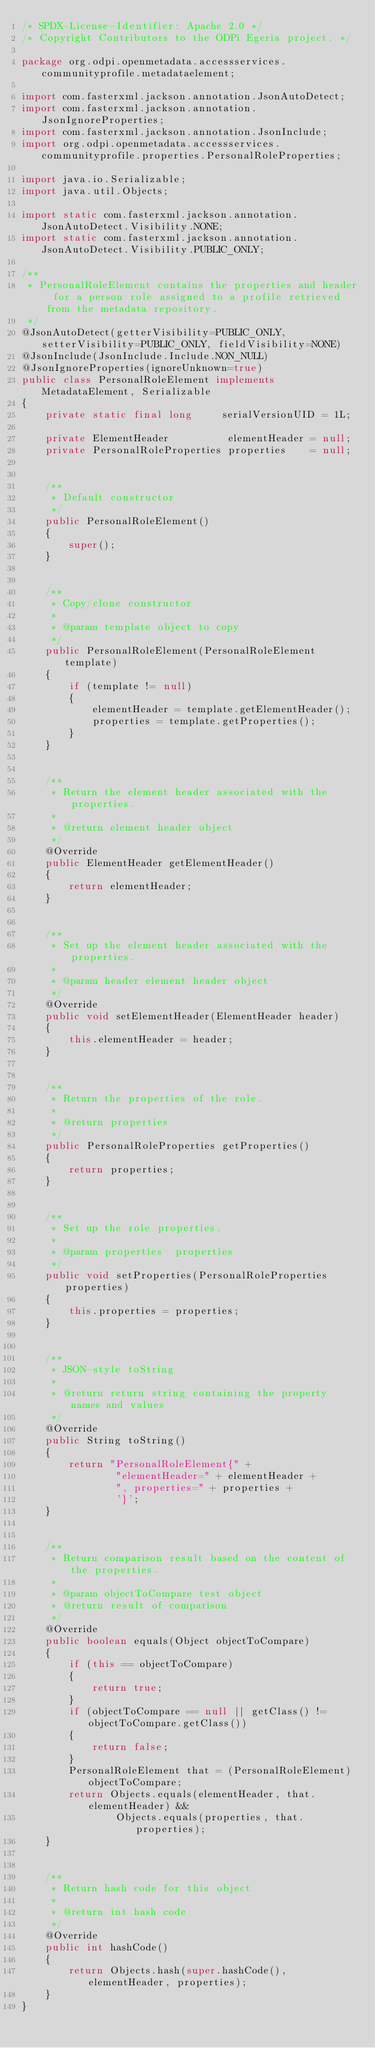<code> <loc_0><loc_0><loc_500><loc_500><_Java_>/* SPDX-License-Identifier: Apache 2.0 */
/* Copyright Contributors to the ODPi Egeria project. */

package org.odpi.openmetadata.accessservices.communityprofile.metadataelement;

import com.fasterxml.jackson.annotation.JsonAutoDetect;
import com.fasterxml.jackson.annotation.JsonIgnoreProperties;
import com.fasterxml.jackson.annotation.JsonInclude;
import org.odpi.openmetadata.accessservices.communityprofile.properties.PersonalRoleProperties;

import java.io.Serializable;
import java.util.Objects;

import static com.fasterxml.jackson.annotation.JsonAutoDetect.Visibility.NONE;
import static com.fasterxml.jackson.annotation.JsonAutoDetect.Visibility.PUBLIC_ONLY;

/**
 * PersonalRoleElement contains the properties and header for a person role assigned to a profile retrieved from the metadata repository.
 */
@JsonAutoDetect(getterVisibility=PUBLIC_ONLY, setterVisibility=PUBLIC_ONLY, fieldVisibility=NONE)
@JsonInclude(JsonInclude.Include.NON_NULL)
@JsonIgnoreProperties(ignoreUnknown=true)
public class PersonalRoleElement implements MetadataElement, Serializable
{
    private static final long     serialVersionUID = 1L;

    private ElementHeader          elementHeader = null;
    private PersonalRoleProperties properties    = null;


    /**
     * Default constructor
     */
    public PersonalRoleElement()
    {
        super();
    }


    /**
     * Copy/clone constructor
     *
     * @param template object to copy
     */
    public PersonalRoleElement(PersonalRoleElement template)
    {
        if (template != null)
        {
            elementHeader = template.getElementHeader();
            properties = template.getProperties();
        }
    }


    /**
     * Return the element header associated with the properties.
     *
     * @return element header object
     */
    @Override
    public ElementHeader getElementHeader()
    {
        return elementHeader;
    }


    /**
     * Set up the element header associated with the properties.
     *
     * @param header element header object
     */
    @Override
    public void setElementHeader(ElementHeader header)
    {
        this.elementHeader = header;
    }


    /**
     * Return the properties of the role.
     *
     * @return properties
     */
    public PersonalRoleProperties getProperties()
    {
        return properties;
    }


    /**
     * Set up the role properties.
     *
     * @param properties  properties
     */
    public void setProperties(PersonalRoleProperties properties)
    {
        this.properties = properties;
    }


    /**
     * JSON-style toString
     *
     * @return return string containing the property names and values
     */
    @Override
    public String toString()
    {
        return "PersonalRoleElement{" +
                "elementHeader=" + elementHeader +
                ", properties=" + properties +
                '}';
    }


    /**
     * Return comparison result based on the content of the properties.
     *
     * @param objectToCompare test object
     * @return result of comparison
     */
    @Override
    public boolean equals(Object objectToCompare)
    {
        if (this == objectToCompare)
        {
            return true;
        }
        if (objectToCompare == null || getClass() != objectToCompare.getClass())
        {
            return false;
        }
        PersonalRoleElement that = (PersonalRoleElement) objectToCompare;
        return Objects.equals(elementHeader, that.elementHeader) &&
                Objects.equals(properties, that.properties);
    }


    /**
     * Return hash code for this object
     *
     * @return int hash code
     */
    @Override
    public int hashCode()
    {
        return Objects.hash(super.hashCode(), elementHeader, properties);
    }
}
</code> 